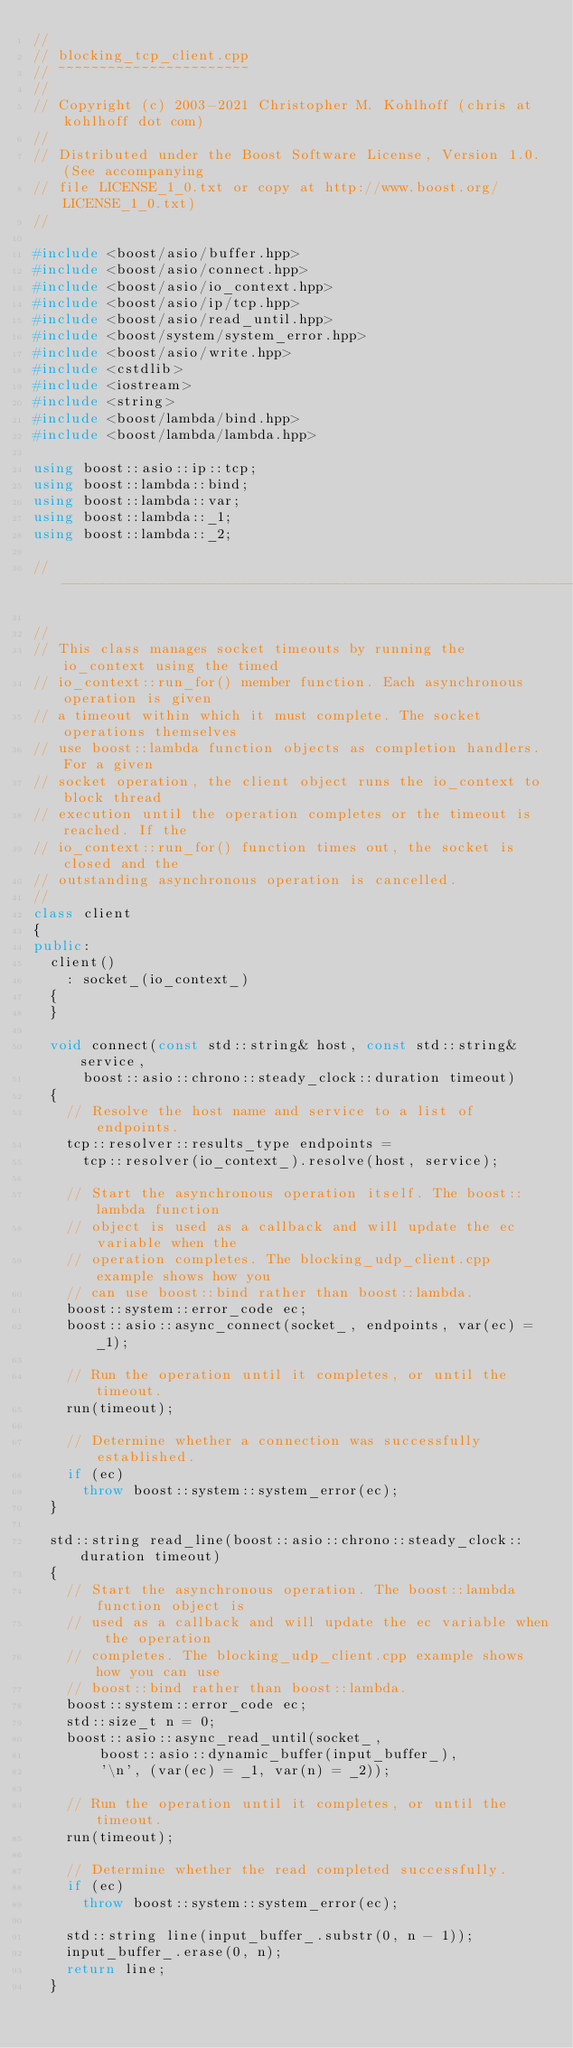<code> <loc_0><loc_0><loc_500><loc_500><_C++_>//
// blocking_tcp_client.cpp
// ~~~~~~~~~~~~~~~~~~~~~~~
//
// Copyright (c) 2003-2021 Christopher M. Kohlhoff (chris at kohlhoff dot com)
//
// Distributed under the Boost Software License, Version 1.0. (See accompanying
// file LICENSE_1_0.txt or copy at http://www.boost.org/LICENSE_1_0.txt)
//

#include <boost/asio/buffer.hpp>
#include <boost/asio/connect.hpp>
#include <boost/asio/io_context.hpp>
#include <boost/asio/ip/tcp.hpp>
#include <boost/asio/read_until.hpp>
#include <boost/system/system_error.hpp>
#include <boost/asio/write.hpp>
#include <cstdlib>
#include <iostream>
#include <string>
#include <boost/lambda/bind.hpp>
#include <boost/lambda/lambda.hpp>

using boost::asio::ip::tcp;
using boost::lambda::bind;
using boost::lambda::var;
using boost::lambda::_1;
using boost::lambda::_2;

//----------------------------------------------------------------------

//
// This class manages socket timeouts by running the io_context using the timed
// io_context::run_for() member function. Each asynchronous operation is given
// a timeout within which it must complete. The socket operations themselves
// use boost::lambda function objects as completion handlers. For a given
// socket operation, the client object runs the io_context to block thread
// execution until the operation completes or the timeout is reached. If the
// io_context::run_for() function times out, the socket is closed and the
// outstanding asynchronous operation is cancelled.
//
class client
{
public:
  client()
    : socket_(io_context_)
  {
  }

  void connect(const std::string& host, const std::string& service,
      boost::asio::chrono::steady_clock::duration timeout)
  {
    // Resolve the host name and service to a list of endpoints.
    tcp::resolver::results_type endpoints =
      tcp::resolver(io_context_).resolve(host, service);

    // Start the asynchronous operation itself. The boost::lambda function
    // object is used as a callback and will update the ec variable when the
    // operation completes. The blocking_udp_client.cpp example shows how you
    // can use boost::bind rather than boost::lambda.
    boost::system::error_code ec;
    boost::asio::async_connect(socket_, endpoints, var(ec) = _1);

    // Run the operation until it completes, or until the timeout.
    run(timeout);

    // Determine whether a connection was successfully established.
    if (ec)
      throw boost::system::system_error(ec);
  }

  std::string read_line(boost::asio::chrono::steady_clock::duration timeout)
  {
    // Start the asynchronous operation. The boost::lambda function object is
    // used as a callback and will update the ec variable when the operation
    // completes. The blocking_udp_client.cpp example shows how you can use
    // boost::bind rather than boost::lambda.
    boost::system::error_code ec;
    std::size_t n = 0;
    boost::asio::async_read_until(socket_,
        boost::asio::dynamic_buffer(input_buffer_),
        '\n', (var(ec) = _1, var(n) = _2));

    // Run the operation until it completes, or until the timeout.
    run(timeout);

    // Determine whether the read completed successfully.
    if (ec)
      throw boost::system::system_error(ec);

    std::string line(input_buffer_.substr(0, n - 1));
    input_buffer_.erase(0, n);
    return line;
  }
</code> 